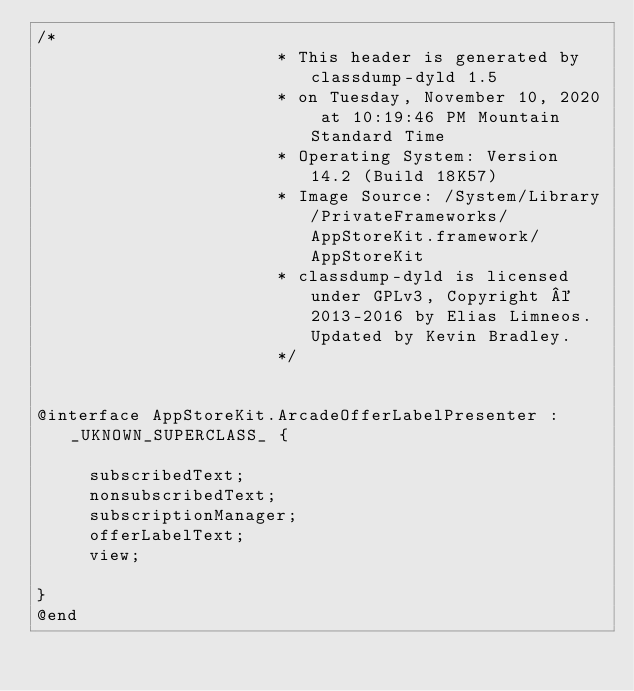<code> <loc_0><loc_0><loc_500><loc_500><_C_>/*
                       * This header is generated by classdump-dyld 1.5
                       * on Tuesday, November 10, 2020 at 10:19:46 PM Mountain Standard Time
                       * Operating System: Version 14.2 (Build 18K57)
                       * Image Source: /System/Library/PrivateFrameworks/AppStoreKit.framework/AppStoreKit
                       * classdump-dyld is licensed under GPLv3, Copyright © 2013-2016 by Elias Limneos. Updated by Kevin Bradley.
                       */


@interface AppStoreKit.ArcadeOfferLabelPresenter : _UKNOWN_SUPERCLASS_ {

	 subscribedText;
	 nonsubscribedText;
	 subscriptionManager;
	 offerLabelText;
	 view;

}
@end

</code> 